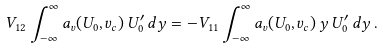Convert formula to latex. <formula><loc_0><loc_0><loc_500><loc_500>V _ { 1 2 } \int _ { - \infty } ^ { \infty } a _ { v } ( U _ { 0 } , v _ { c } ) \, U _ { 0 } ^ { \prime } \, d y = - V _ { 1 1 } \int _ { - \infty } ^ { \infty } a _ { v } ( U _ { 0 } , v _ { c } ) \, y \, U _ { 0 } ^ { \prime } \, d y \, .</formula> 